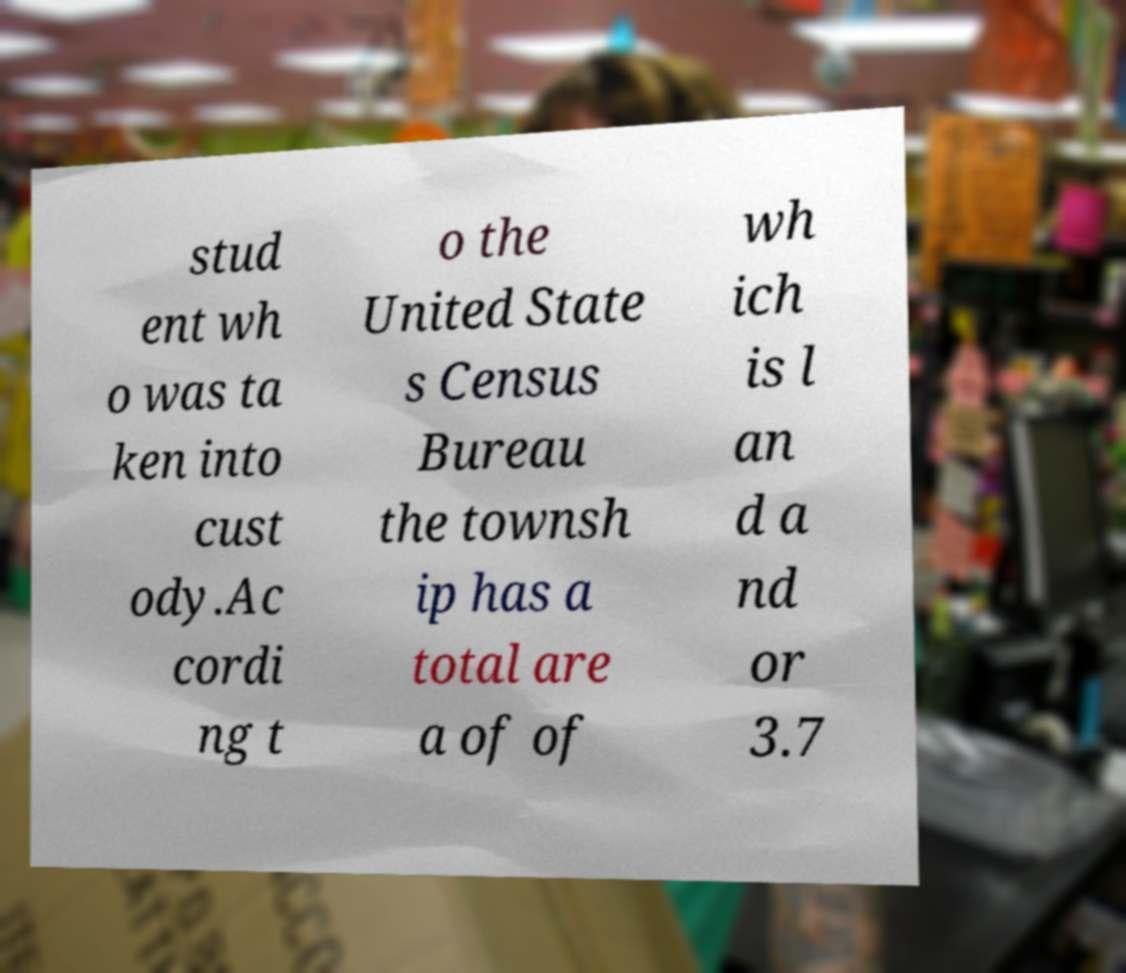There's text embedded in this image that I need extracted. Can you transcribe it verbatim? stud ent wh o was ta ken into cust ody.Ac cordi ng t o the United State s Census Bureau the townsh ip has a total are a of of wh ich is l an d a nd or 3.7 